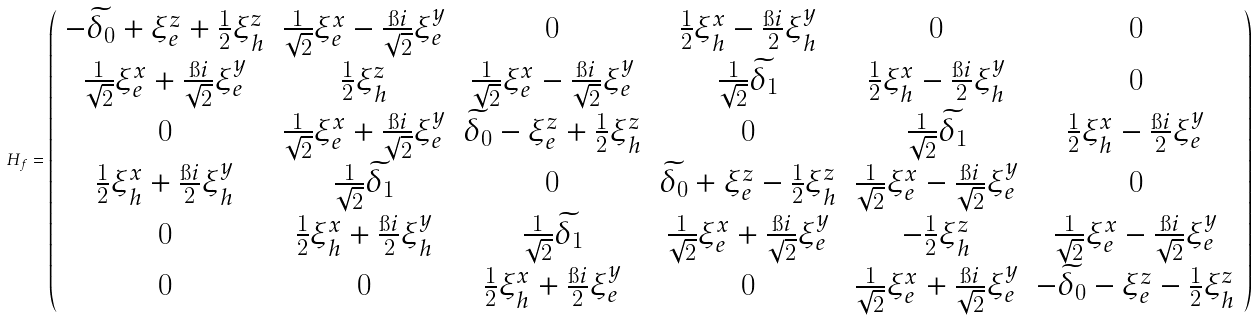<formula> <loc_0><loc_0><loc_500><loc_500>H _ { f } = \left ( \begin{array} { c c c c c c } - \widetilde { \delta _ { 0 } } + \xi _ { e } ^ { z } + \frac { 1 } { 2 } \xi _ { h } ^ { z } & \frac { 1 } { \sqrt { 2 } } \xi _ { e } ^ { x } - \frac { \i i } { \sqrt { 2 } } \xi _ { e } ^ { y } & 0 & \frac { 1 } { 2 } \xi _ { h } ^ { x } - \frac { \i i } { 2 } \xi _ { h } ^ { y } & 0 & 0 \\ \frac { 1 } { \sqrt { 2 } } \xi _ { e } ^ { x } + \frac { \i i } { \sqrt { 2 } } \xi _ { e } ^ { y } & \frac { 1 } { 2 } \xi _ { h } ^ { z } & \frac { 1 } { \sqrt { 2 } } \xi _ { e } ^ { x } - \frac { \i i } { \sqrt { 2 } } \xi _ { e } ^ { y } & \frac { 1 } { \sqrt { 2 } } \widetilde { \delta _ { 1 } } & \frac { 1 } { 2 } \xi _ { h } ^ { x } - \frac { \i i } { 2 } \xi _ { h } ^ { y } & 0 \\ 0 & \frac { 1 } { \sqrt { 2 } } \xi _ { e } ^ { x } + \frac { \i i } { \sqrt { 2 } } \xi _ { e } ^ { y } & \widetilde { \delta _ { 0 } } - \xi _ { e } ^ { z } + \frac { 1 } { 2 } \xi _ { h } ^ { z } & 0 & \frac { 1 } { \sqrt { 2 } } \widetilde { \delta _ { 1 } } & \frac { 1 } { 2 } \xi _ { h } ^ { x } - \frac { \i i } { 2 } \xi _ { e } ^ { y } \\ \frac { 1 } { 2 } \xi _ { h } ^ { x } + \frac { \i i } { 2 } \xi _ { h } ^ { y } & \frac { 1 } { \sqrt { 2 } } \widetilde { \delta _ { 1 } } & 0 & \widetilde { \delta _ { 0 } } + \xi _ { e } ^ { z } - \frac { 1 } { 2 } \xi _ { h } ^ { z } & \frac { 1 } { \sqrt { 2 } } \xi _ { e } ^ { x } - \frac { \i i } { \sqrt { 2 } } \xi _ { e } ^ { y } & 0 \\ 0 & \frac { 1 } { 2 } \xi _ { h } ^ { x } + \frac { \i i } { 2 } \xi _ { h } ^ { y } & \frac { 1 } { \sqrt { 2 } } \widetilde { \delta _ { 1 } } & \frac { 1 } { \sqrt { 2 } } \xi _ { e } ^ { x } + \frac { \i i } { \sqrt { 2 } } \xi _ { e } ^ { y } & - \frac { 1 } { 2 } \xi _ { h } ^ { z } & \frac { 1 } { \sqrt { 2 } } \xi _ { e } ^ { x } - \frac { \i i } { \sqrt { 2 } } \xi _ { e } ^ { y } \\ 0 & 0 & \frac { 1 } { 2 } \xi _ { h } ^ { x } + \frac { \i i } { 2 } \xi _ { e } ^ { y } & 0 & \frac { 1 } { \sqrt { 2 } } \xi _ { e } ^ { x } + \frac { \i i } { \sqrt { 2 } } \xi _ { e } ^ { y } & - \widetilde { \delta _ { 0 } } - \xi _ { e } ^ { z } - \frac { 1 } { 2 } \xi _ { h } ^ { z } \end{array} \right )</formula> 